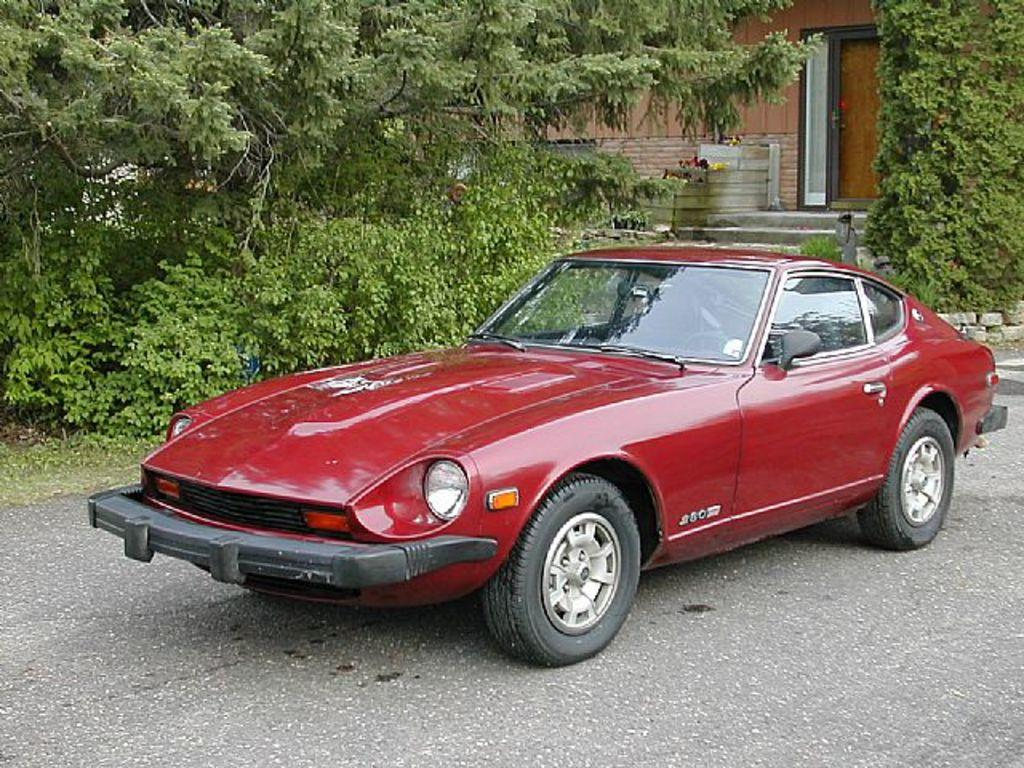What is the main subject of the image? There is a vehicle on the road in the image. What can be seen in the background of the image? There is a wall and stones in the background of the image. Are there any other objects visible in the background? Yes, there are other objects visible in the background of the image. What type of yam is being used as a selection tool in the image? There is no yam present in the image, and therefore no such tool can be observed. 